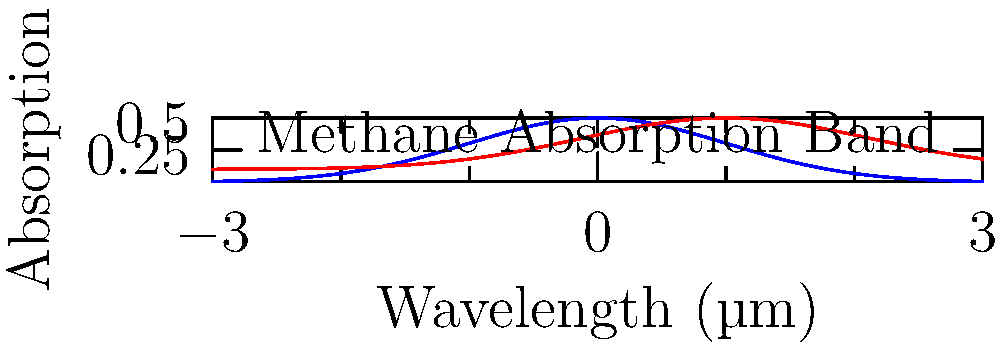Given the observed spectral data (red curve) and the null hypothesis model (blue curve) for an exoplanet atmosphere, calculate the p-value for the presence of methane. Assume the test statistic follows a chi-squared distribution with 10 degrees of freedom, and the calculated test statistic is 18.5. What conclusion can be drawn about the statistical significance of this potential biosignature at a significance level of $\alpha = 0.05$? To determine the statistical significance of the potential methane biosignature, we'll follow these steps:

1) We have a chi-squared test statistic of 18.5 with 10 degrees of freedom.

2) The p-value is the probability of observing a test statistic as extreme as 18.5, assuming the null hypothesis is true.

3) For a chi-squared distribution with 10 degrees of freedom:
   $P(\chi^2 > 18.5) = 1 - P(\chi^2 \leq 18.5)$

4) Using a chi-squared distribution table or calculator:
   $P(\chi^2 > 18.5) \approx 0.0470$

5) The p-value is approximately 0.0470.

6) Compare this to our significance level $\alpha = 0.05$:
   0.0470 < 0.05

7) Since the p-value is less than the significance level, we reject the null hypothesis.

8) In the context of our problem:
   - Null hypothesis: No significant methane present
   - Alternative hypothesis: Significant methane present

9) Rejecting the null hypothesis suggests that the observed spectral data shows statistically significant evidence for the presence of methane in the exoplanet's atmosphere.

10) However, note that statistical significance doesn't necessarily imply biological origin. Further investigation would be needed to determine if this methane is a true biosignature.
Answer: Reject null hypothesis; statistically significant evidence for methane (p = 0.0470 < 0.05). 